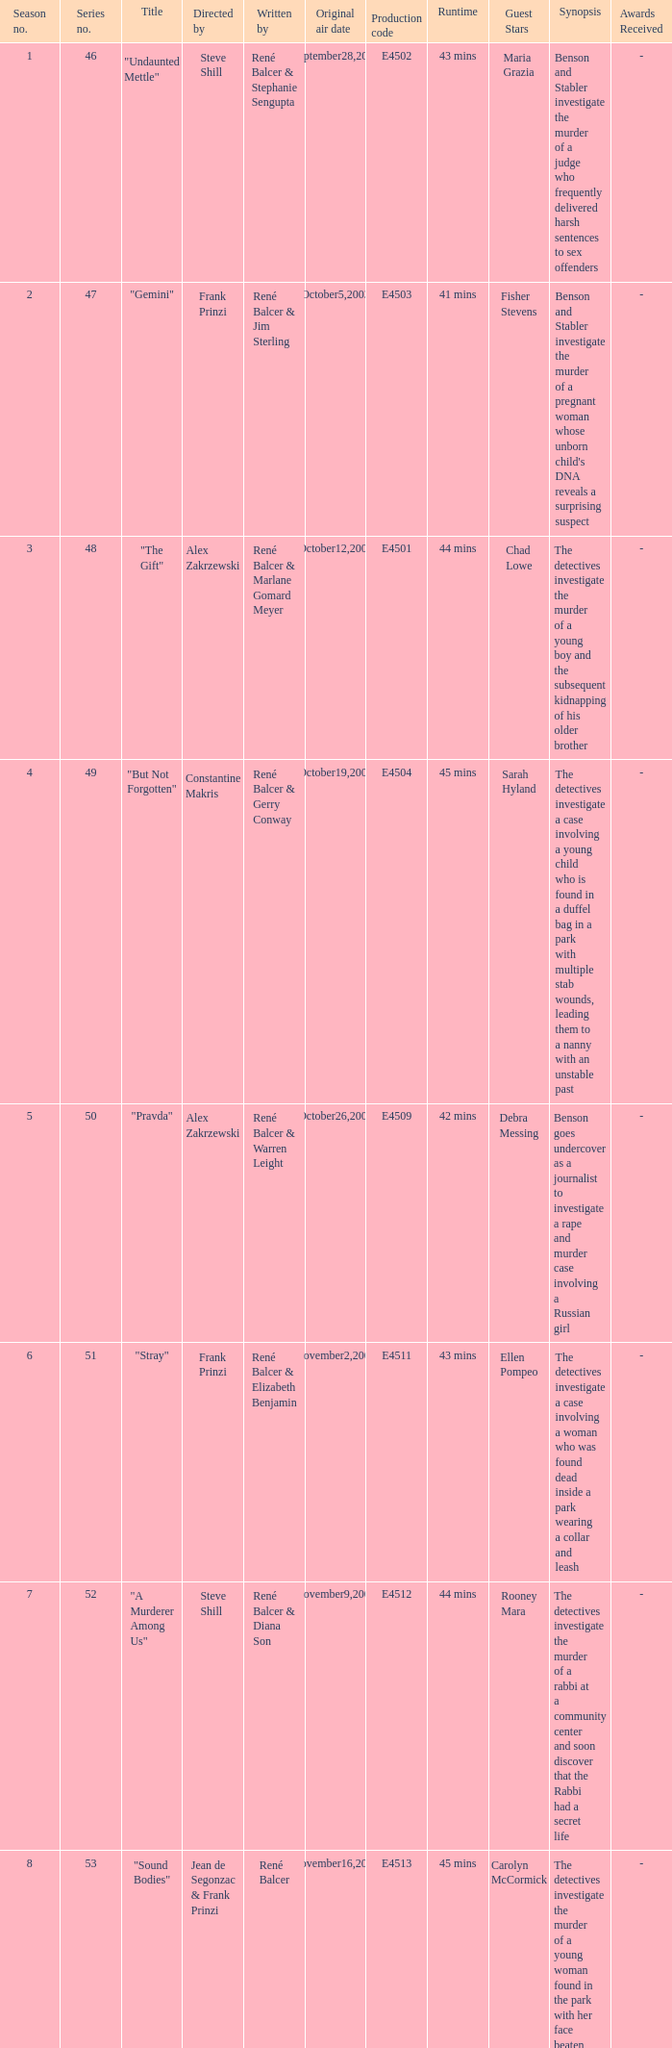What date did "d.a.w." Originally air? May16,2004. 